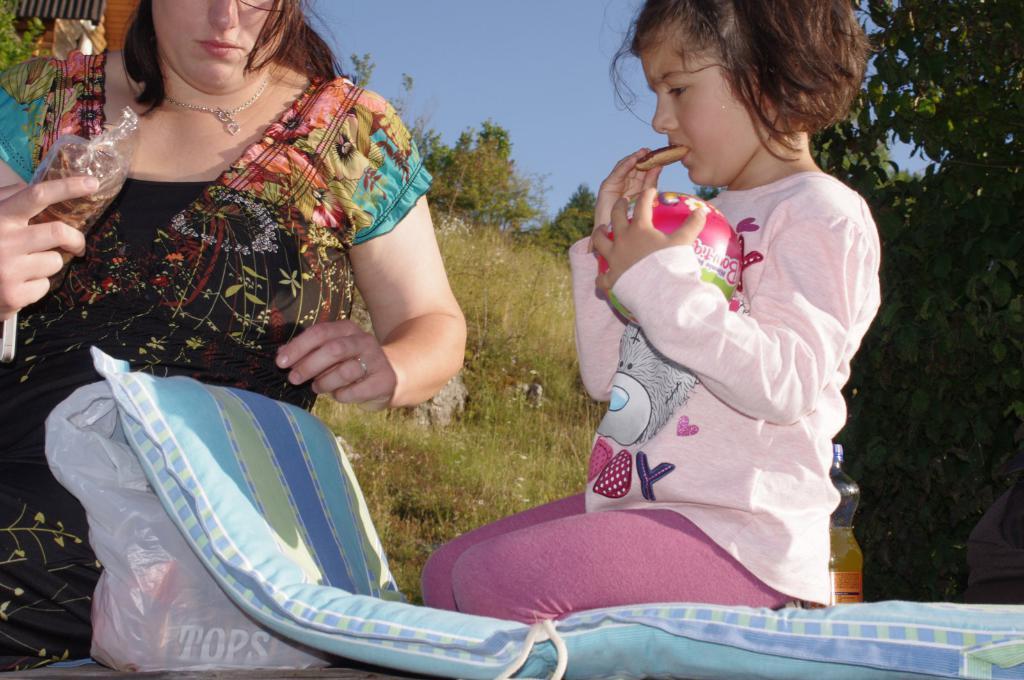Can you describe this image briefly? In this image I can see two persons, the person at right is wearing pink color dress and the person at left is wearing black, brown and green color dress and the person is holding a cover. Background I can see trees and plants in green color and the sky is in blue color. 